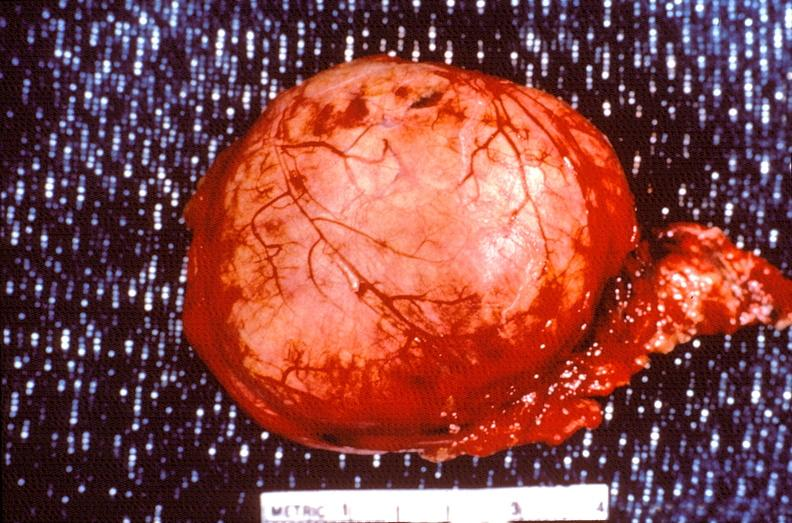does stillborn cord around neck show pituitary, chromaphobe adenoma?
Answer the question using a single word or phrase. No 